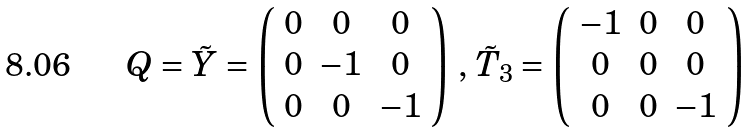<formula> <loc_0><loc_0><loc_500><loc_500>Q = \tilde { Y } = \left ( \begin{array} { c c c } 0 & 0 & 0 \\ 0 & - 1 & 0 \\ 0 & 0 & - 1 \end{array} \right ) \, , \, \tilde { T } _ { 3 } = \left ( \begin{array} { c c c } - 1 & 0 & 0 \\ 0 & 0 & 0 \\ 0 & 0 & - 1 \end{array} \right )</formula> 